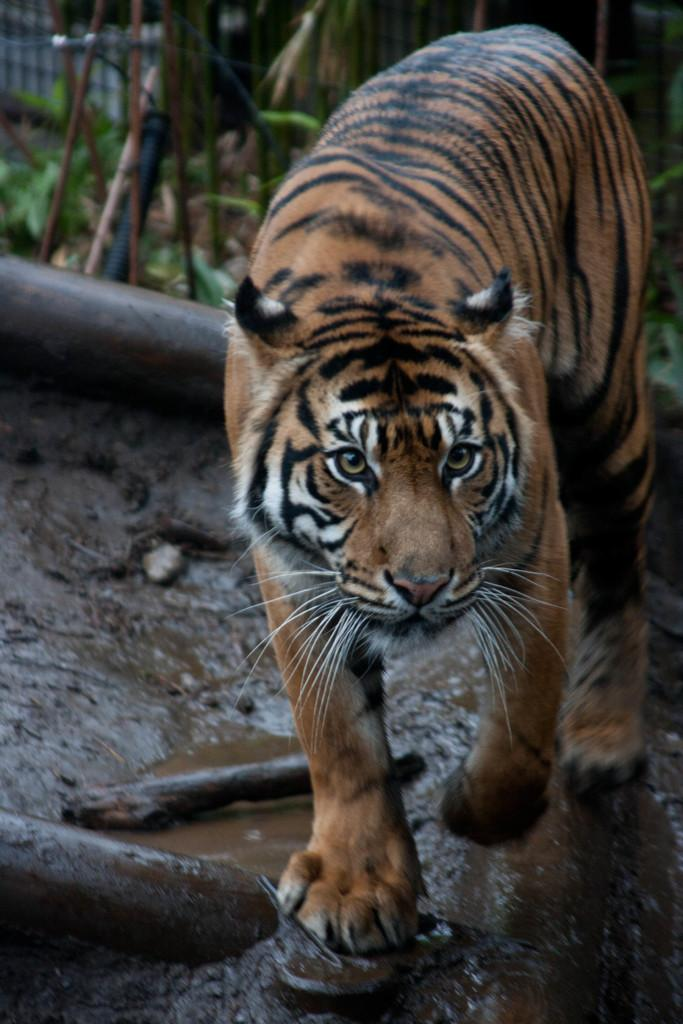What is the main subject in the center of the image? There is a tiger in the center of the image. What color is the object in the image? There is a black color object in the image. What are the rods used for in the image? The purpose of the rods in the image is not specified, but they are present. What natural elements can be seen in the image? There is water and mud in the image. How would you describe the background of the image? The background of the image is blurred. What type of destruction can be seen on the side of the image? There is no destruction visible in the image; it features a tiger, a black object, rods, water, mud, and a blurred background. 